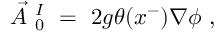Convert formula to latex. <formula><loc_0><loc_0><loc_500><loc_500>\vec { A } _ { 0 } ^ { I } = 2 g \theta ( x ^ { - } ) \nabla \phi ,</formula> 